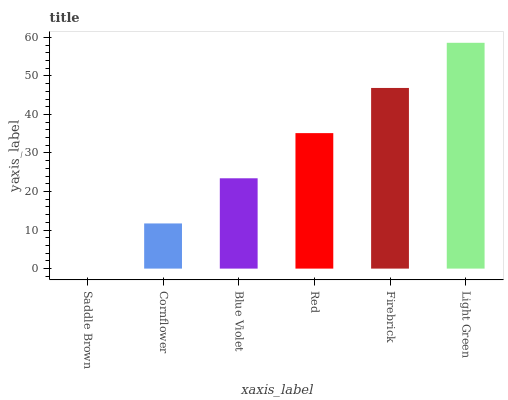Is Saddle Brown the minimum?
Answer yes or no. Yes. Is Light Green the maximum?
Answer yes or no. Yes. Is Cornflower the minimum?
Answer yes or no. No. Is Cornflower the maximum?
Answer yes or no. No. Is Cornflower greater than Saddle Brown?
Answer yes or no. Yes. Is Saddle Brown less than Cornflower?
Answer yes or no. Yes. Is Saddle Brown greater than Cornflower?
Answer yes or no. No. Is Cornflower less than Saddle Brown?
Answer yes or no. No. Is Red the high median?
Answer yes or no. Yes. Is Blue Violet the low median?
Answer yes or no. Yes. Is Firebrick the high median?
Answer yes or no. No. Is Light Green the low median?
Answer yes or no. No. 